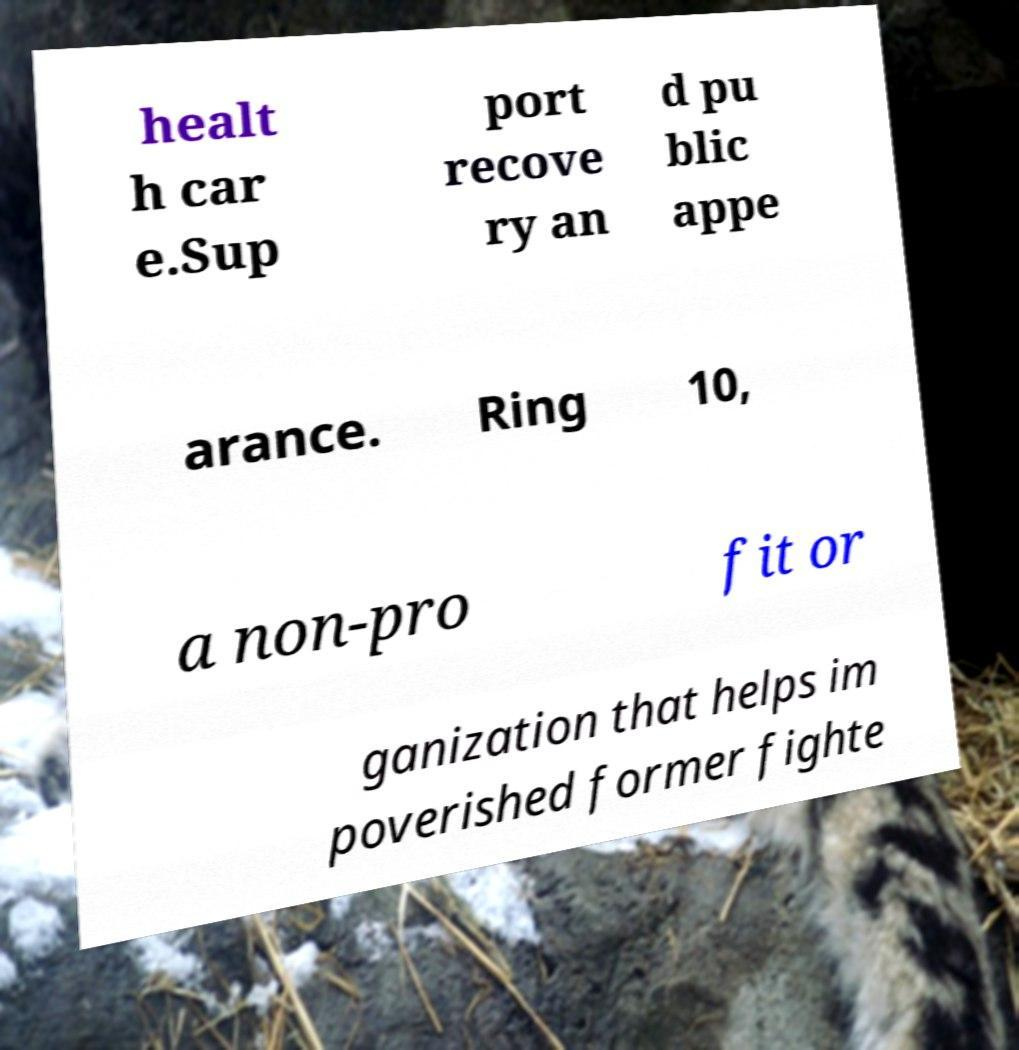Can you read and provide the text displayed in the image?This photo seems to have some interesting text. Can you extract and type it out for me? healt h car e.Sup port recove ry an d pu blic appe arance. Ring 10, a non-pro fit or ganization that helps im poverished former fighte 